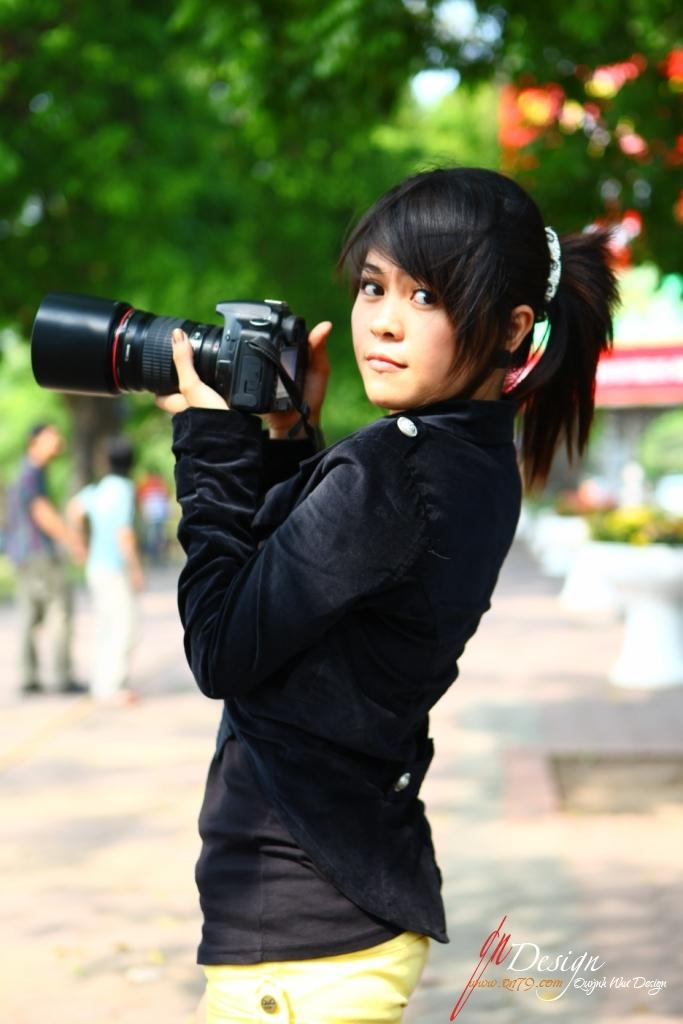What is the woman in the image holding? The woman is holding a camera. What is the woman's posture in the image? The woman is standing. How many people are visible in the background of the image? There are 3 persons in the background of the image. What type of natural environment is visible in the background of the image? There are trees and a path visible in the background of the image. What type of plate is the woman using to take the photo in the image? There is no plate present in the image; the woman is holding a camera. Can you tell me how many airports are visible in the image? There are no airports visible in the image. 